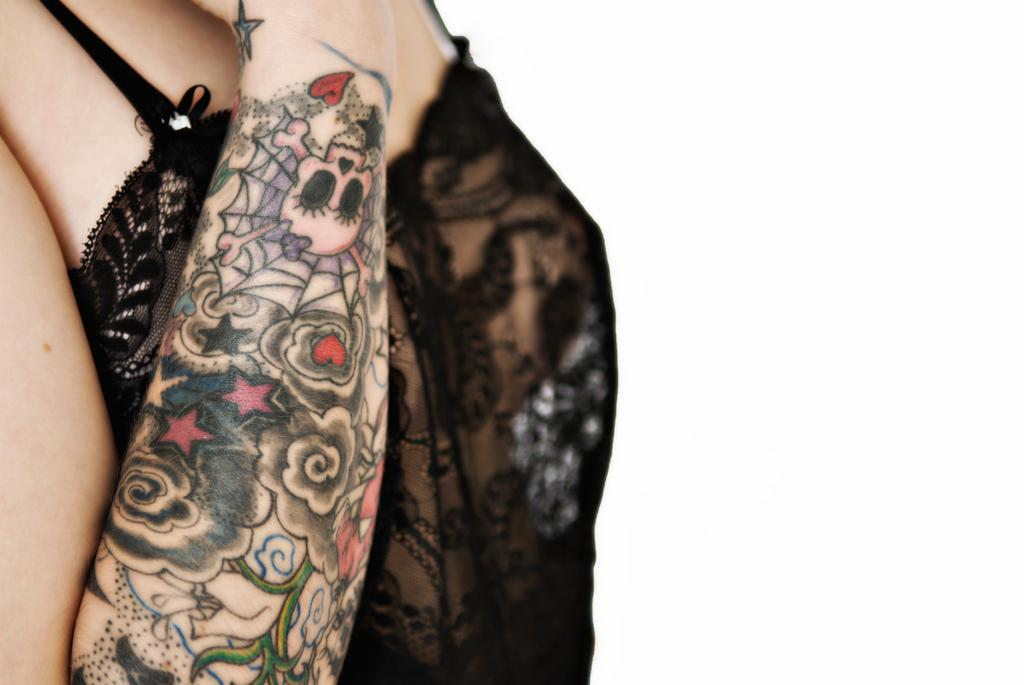What is the main subject of the image? There is a woman in the image. What is the woman wearing? The woman is wearing a black dress. How is the woman described in the image? The woman is described as stunning. What type of quiver can be seen in the image? There is no quiver present in the image. How many people are in the crowd in the image? There is no crowd present in the image. What type of car is visible in the image? There is no car present in the image. 